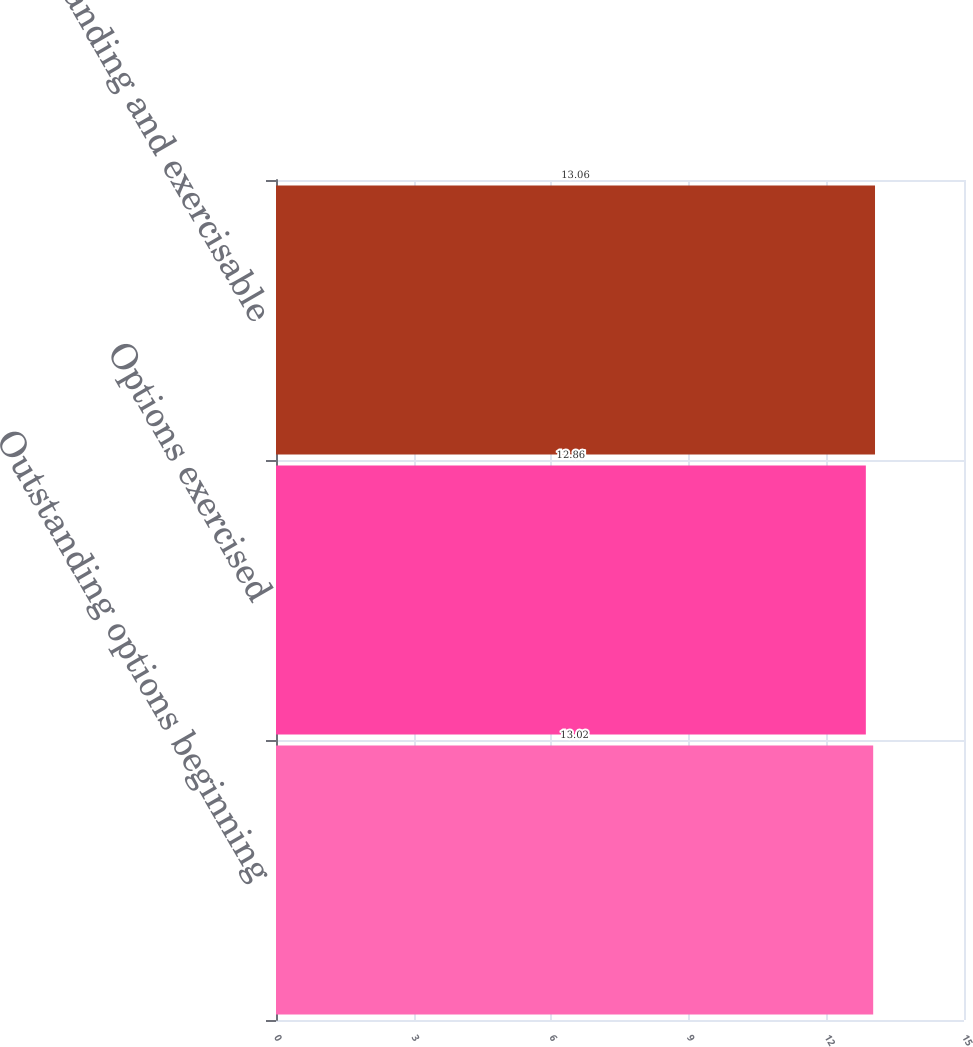<chart> <loc_0><loc_0><loc_500><loc_500><bar_chart><fcel>Outstanding options beginning<fcel>Options exercised<fcel>Outstanding and exercisable<nl><fcel>13.02<fcel>12.86<fcel>13.06<nl></chart> 